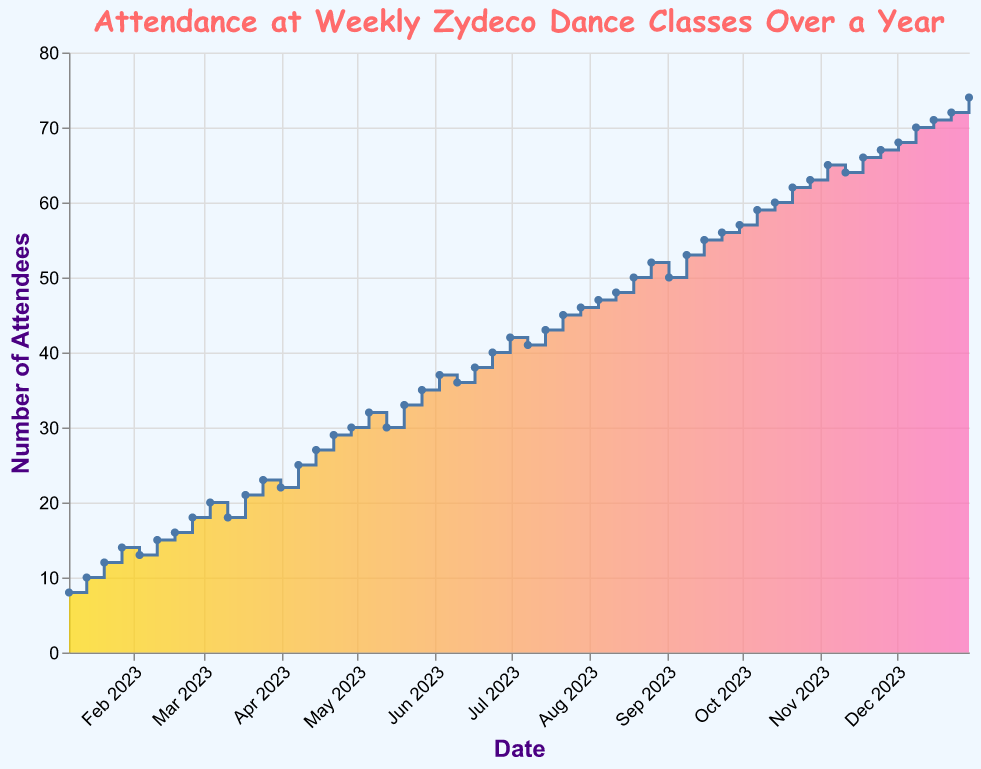When does the attendance first reach 20 people? Look for the first data point where the y-axis (attendance) reaches 20. This occurs at week 9, which corresponds to the date March 4, 2023.
Answer: March 4, 2023 What is the peak attendance during the year? Identify the highest value on the y-axis representing attendance. The peak value is 74, which occurs at week 52.
Answer: 74 What is the trend in attendance from January to June? Analyze the attendance values from January (week 1) to June (week 24). The values generally increase from 8 to 38, with minor fluctuations. Thus, there is an overall increasing trend.
Answer: Increasing How much does attendance increase from the first week to the last week? Determine the attendance in the first week (8) and the last week (74). Calculate the difference: 74 - 8 = 66.
Answer: 66 Is there any point where the attendance decreases from one week to the next? Identify weeks where the y-values decrease. This occurs from week 4 to week 5 (14 to 13), week 10 to week 11 (20 to 18), and a few other instances.
Answer: Yes Which month shows the highest growth in attendance? Identify the month where the increase in attendance is the largest by comparing beginning and end values for each month. August goes from 47 to 52, a 5 person increase, which is one of the significant monthly gains.
Answer: August What is the average weekly attendance over the year? Sum the attendance values and divide by the number of weeks (52). Sum = 1686, so average = 1686/52 ≈ 32.42.
Answer: 32.42 Are there any months where attendance shows a decline? Check each month for instances where the end value is lower than the start. November shows a slight decline, from 65 to 64, and then back up.
Answer: November What's the attendance difference between the highest and lowest points in July? Identify the highest (45 at week 29) and lowest (41 at week 27) attendance in July, then subtract the lower from the higher: 45 - 41 = 4.
Answer: 4 Is there a steady increase in attendance from October to December? Check attendance values from the start of October (week 40) to the end of December (week 52). The values consistently increase from 59 to 74, showing a steady rise.
Answer: Yes 